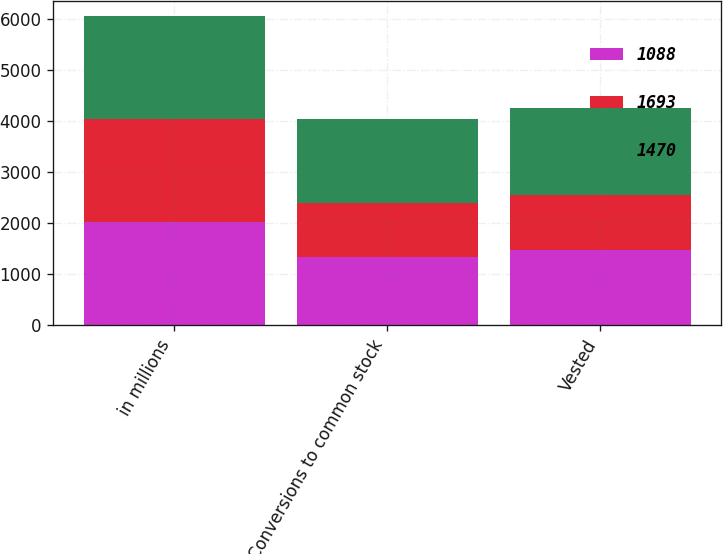Convert chart to OTSL. <chart><loc_0><loc_0><loc_500><loc_500><stacked_bar_chart><ecel><fcel>in millions<fcel>Conversions to common stock<fcel>Vested<nl><fcel>1088<fcel>2017<fcel>1333<fcel>1470<nl><fcel>1693<fcel>2016<fcel>1068<fcel>1088<nl><fcel>1470<fcel>2015<fcel>1646<fcel>1693<nl></chart> 